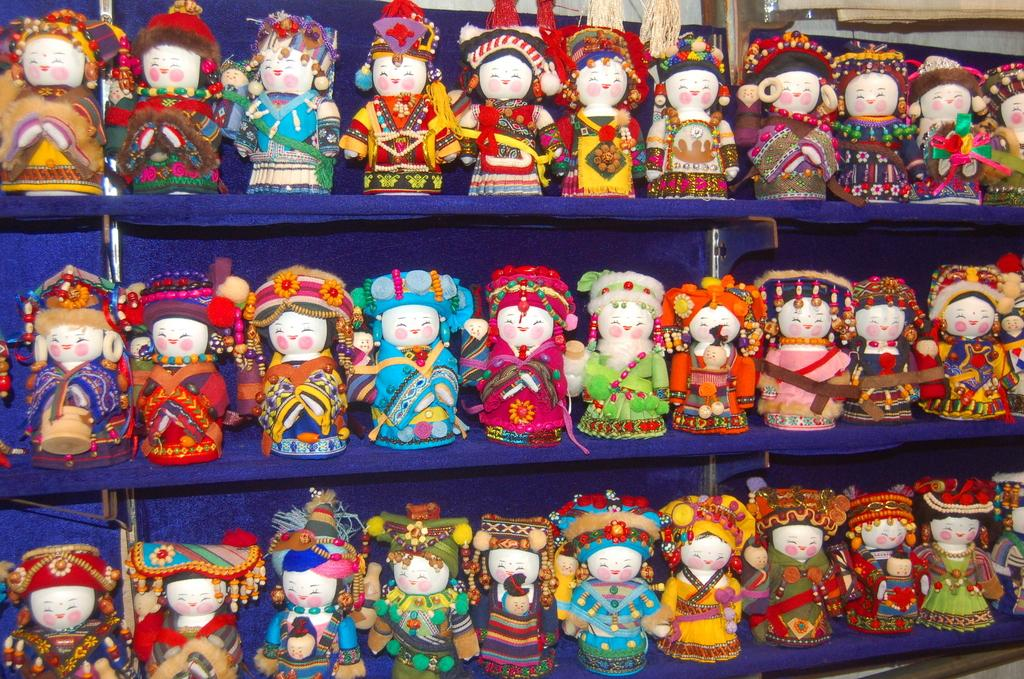What type of objects can be seen in the image? There are dolls present in the image. How are the dolls arranged in the image? The dolls are placed in racks. What type of crack can be seen in the image? There is no crack present in the image. What vase is depicted in the image? There is no vase present in the image. 